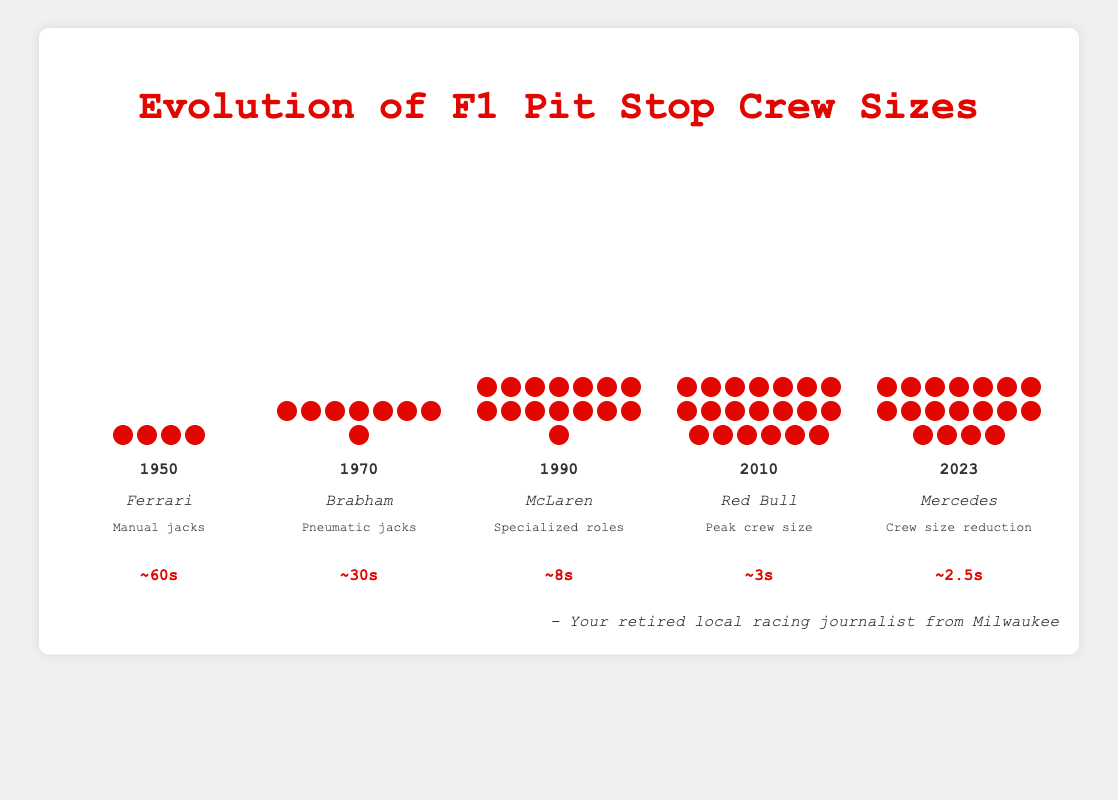What is the title of the figure? The title is found at the top of the figure and is typically the largest text, clearly indicating the subject of the visualization.
Answer: Evolution of F1 Pit Stop Crew Sizes Which year had the peak crew size? The crew size is represented by the number of icons in each year column. The column for 2010 contains the maximum number of icons.
Answer: 2010 How did the average pit stop time change from 1950 to 2023? The figure shows the pit stop times at the bottom of each year column. In 1950, it was 60 seconds, and in 2023, it was 2.5 seconds. The difference is 60 - 2.5 = 57.5 seconds.
Answer: Decreased by 57.5 seconds Which team had an average pit stop time of around 8 seconds? The average pit stop times are listed under each year's section. The column for 1990 shows a pit stop time of approximately 8 seconds, and the associated team is McLaren.
Answer: McLaren How many crew members were there in 1970 compared to 1950? Counting the crew icons in each year's column, 1970 had 8 members, and 1950 had 4 members. The difference is 8 - 4 = 4 members.
Answer: 4 more members What notable change occurred in 2010? Each year column includes a label for notable changes. In the column for 2010, it mentions "Peak crew size."
Answer: Peak crew size Between which two years did the pit stop time see the most significant decrease? By comparing the average pit stop times, the most significant drop is observed between 1970 (30s) and 1990 (8s), a decrease of 22 seconds.
Answer: 1970 and 1990 What trend is observed in crew sizes from 1950 to 2023? Observing the crew icons, the trend is an increase from 4 members in 1950 to a peak of 20 in 2010, followed by a slight reduction to 18 in 2023.
Answer: Increased then slightly decreased 